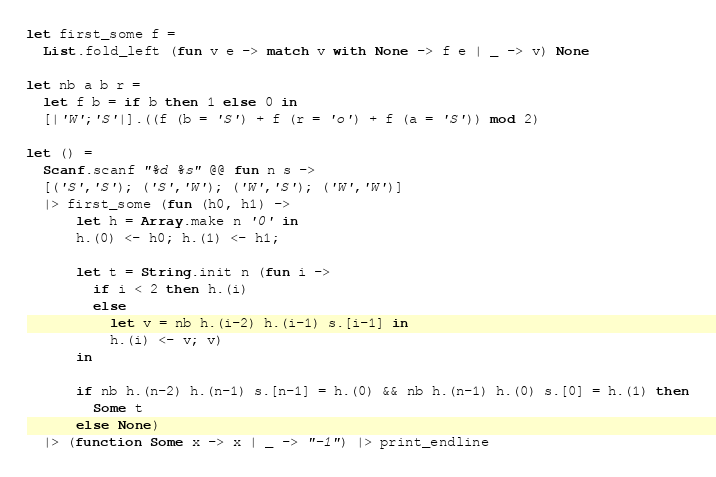Convert code to text. <code><loc_0><loc_0><loc_500><loc_500><_OCaml_>let first_some f =
  List.fold_left (fun v e -> match v with None -> f e | _ -> v) None

let nb a b r =
  let f b = if b then 1 else 0 in
  [|'W';'S'|].((f (b = 'S') + f (r = 'o') + f (a = 'S')) mod 2)

let () =
  Scanf.scanf "%d %s" @@ fun n s ->
  [('S','S'); ('S','W'); ('W','S'); ('W','W')]
  |> first_some (fun (h0, h1) ->
      let h = Array.make n '0' in
      h.(0) <- h0; h.(1) <- h1;

      let t = String.init n (fun i ->
        if i < 2 then h.(i)
        else
          let v = nb h.(i-2) h.(i-1) s.[i-1] in
          h.(i) <- v; v)
      in

      if nb h.(n-2) h.(n-1) s.[n-1] = h.(0) && nb h.(n-1) h.(0) s.[0] = h.(1) then
        Some t
      else None)
  |> (function Some x -> x | _ -> "-1") |> print_endline</code> 